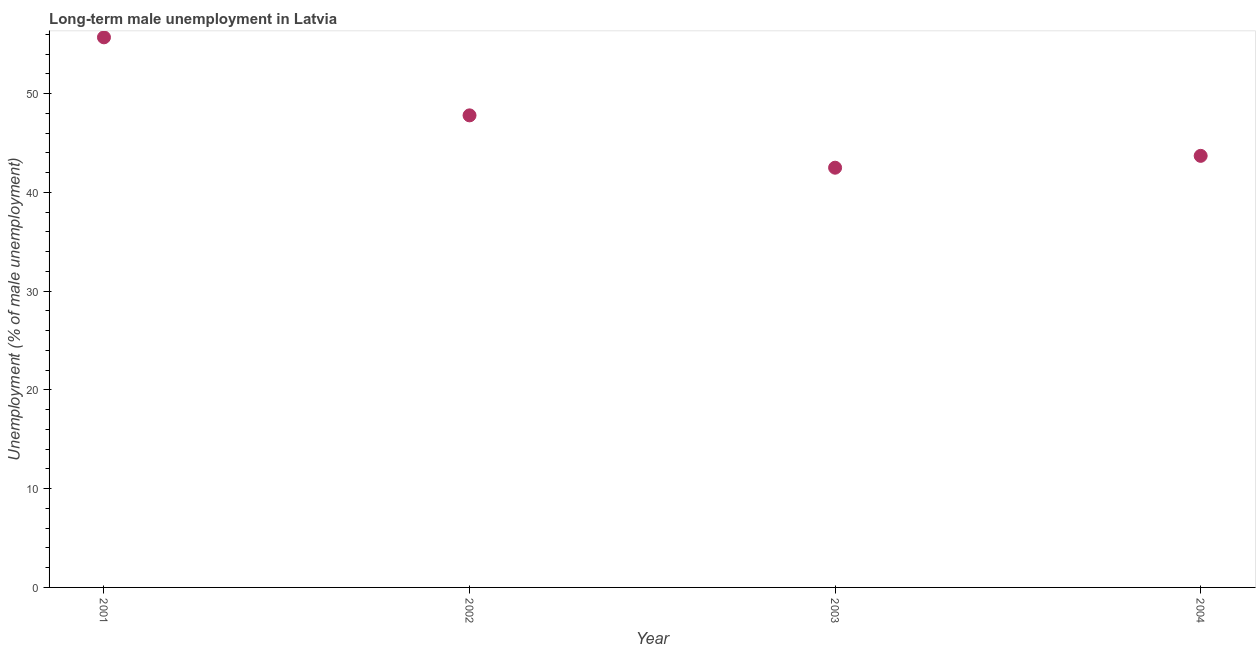What is the long-term male unemployment in 2003?
Provide a short and direct response. 42.5. Across all years, what is the maximum long-term male unemployment?
Provide a short and direct response. 55.7. Across all years, what is the minimum long-term male unemployment?
Give a very brief answer. 42.5. What is the sum of the long-term male unemployment?
Give a very brief answer. 189.7. What is the difference between the long-term male unemployment in 2002 and 2003?
Your answer should be compact. 5.3. What is the average long-term male unemployment per year?
Provide a short and direct response. 47.43. What is the median long-term male unemployment?
Keep it short and to the point. 45.75. In how many years, is the long-term male unemployment greater than 4 %?
Make the answer very short. 4. What is the ratio of the long-term male unemployment in 2001 to that in 2004?
Make the answer very short. 1.27. Is the long-term male unemployment in 2002 less than that in 2004?
Give a very brief answer. No. Is the difference between the long-term male unemployment in 2002 and 2003 greater than the difference between any two years?
Provide a short and direct response. No. What is the difference between the highest and the second highest long-term male unemployment?
Keep it short and to the point. 7.9. What is the difference between the highest and the lowest long-term male unemployment?
Offer a terse response. 13.2. What is the title of the graph?
Your answer should be very brief. Long-term male unemployment in Latvia. What is the label or title of the X-axis?
Your answer should be very brief. Year. What is the label or title of the Y-axis?
Keep it short and to the point. Unemployment (% of male unemployment). What is the Unemployment (% of male unemployment) in 2001?
Your answer should be compact. 55.7. What is the Unemployment (% of male unemployment) in 2002?
Ensure brevity in your answer.  47.8. What is the Unemployment (% of male unemployment) in 2003?
Your answer should be very brief. 42.5. What is the Unemployment (% of male unemployment) in 2004?
Make the answer very short. 43.7. What is the difference between the Unemployment (% of male unemployment) in 2001 and 2002?
Make the answer very short. 7.9. What is the difference between the Unemployment (% of male unemployment) in 2001 and 2003?
Provide a succinct answer. 13.2. What is the ratio of the Unemployment (% of male unemployment) in 2001 to that in 2002?
Your answer should be very brief. 1.17. What is the ratio of the Unemployment (% of male unemployment) in 2001 to that in 2003?
Offer a very short reply. 1.31. What is the ratio of the Unemployment (% of male unemployment) in 2001 to that in 2004?
Your response must be concise. 1.27. What is the ratio of the Unemployment (% of male unemployment) in 2002 to that in 2003?
Offer a terse response. 1.12. What is the ratio of the Unemployment (% of male unemployment) in 2002 to that in 2004?
Give a very brief answer. 1.09. 